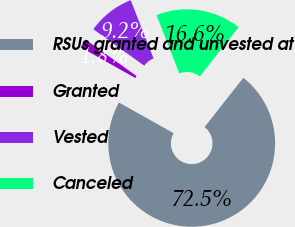Convert chart to OTSL. <chart><loc_0><loc_0><loc_500><loc_500><pie_chart><fcel>RSUs granted and unvested at<fcel>Granted<fcel>Vested<fcel>Canceled<nl><fcel>72.51%<fcel>1.75%<fcel>9.16%<fcel>16.58%<nl></chart> 